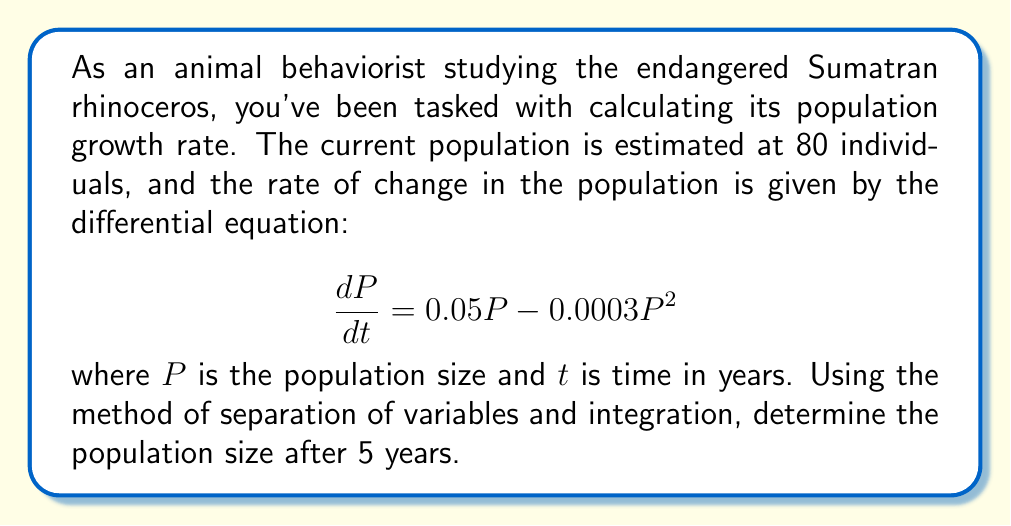What is the answer to this math problem? 1. Start with the given differential equation:
   $$\frac{dP}{dt} = 0.05P - 0.0003P^2$$

2. Separate the variables:
   $$\frac{dP}{0.05P - 0.0003P^2} = dt$$

3. Integrate both sides:
   $$\int \frac{dP}{0.05P - 0.0003P^2} = \int dt$$

4. The left-hand side can be integrated using partial fractions:
   $$\frac{1}{0.05} \int \left(\frac{1}{P} + \frac{0.006}{0.05 - 0.0003P}\right) dP = t + C$$

5. Evaluate the integral:
   $$\frac{1}{0.05} [\ln|P| - \frac{1}{0.006}\ln|0.05 - 0.0003P|] = t + C$$

6. Apply the initial condition: At $t=0$, $P=80$:
   $$\frac{1}{0.05} [\ln(80) - \frac{1}{0.006}\ln(0.05 - 0.0003 \cdot 80)] = C$$

7. Substitute this value of $C$ back into the equation and simplify:
   $$\ln\left(\frac{P}{80}\right) - \frac{1}{0.006}\ln\left(\frac{0.05 - 0.0003P}{0.026}\right) = 0.05t$$

8. To find $P$ after 5 years, substitute $t=5$ and solve numerically (as it's difficult to isolate $P$ algebraically).

9. Using numerical methods or a graphing calculator, we find that $P \approx 97.3$ after 5 years.
Answer: 97.3 Sumatran rhinoceros 